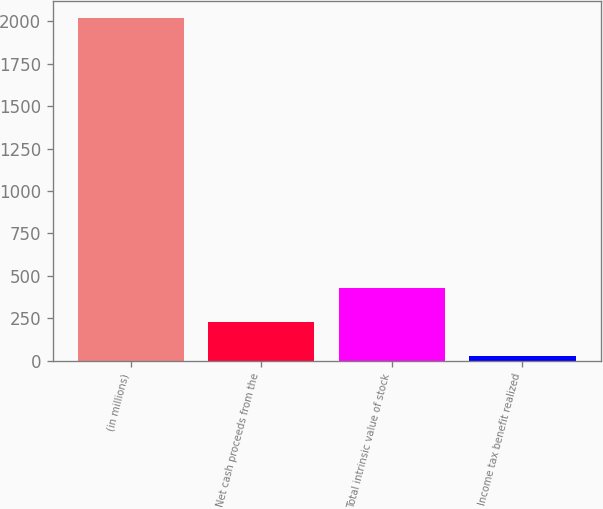Convert chart. <chart><loc_0><loc_0><loc_500><loc_500><bar_chart><fcel>(in millions)<fcel>Net cash proceeds from the<fcel>Total intrinsic value of stock<fcel>Income tax benefit realized<nl><fcel>2018<fcel>226.1<fcel>425.2<fcel>27<nl></chart> 